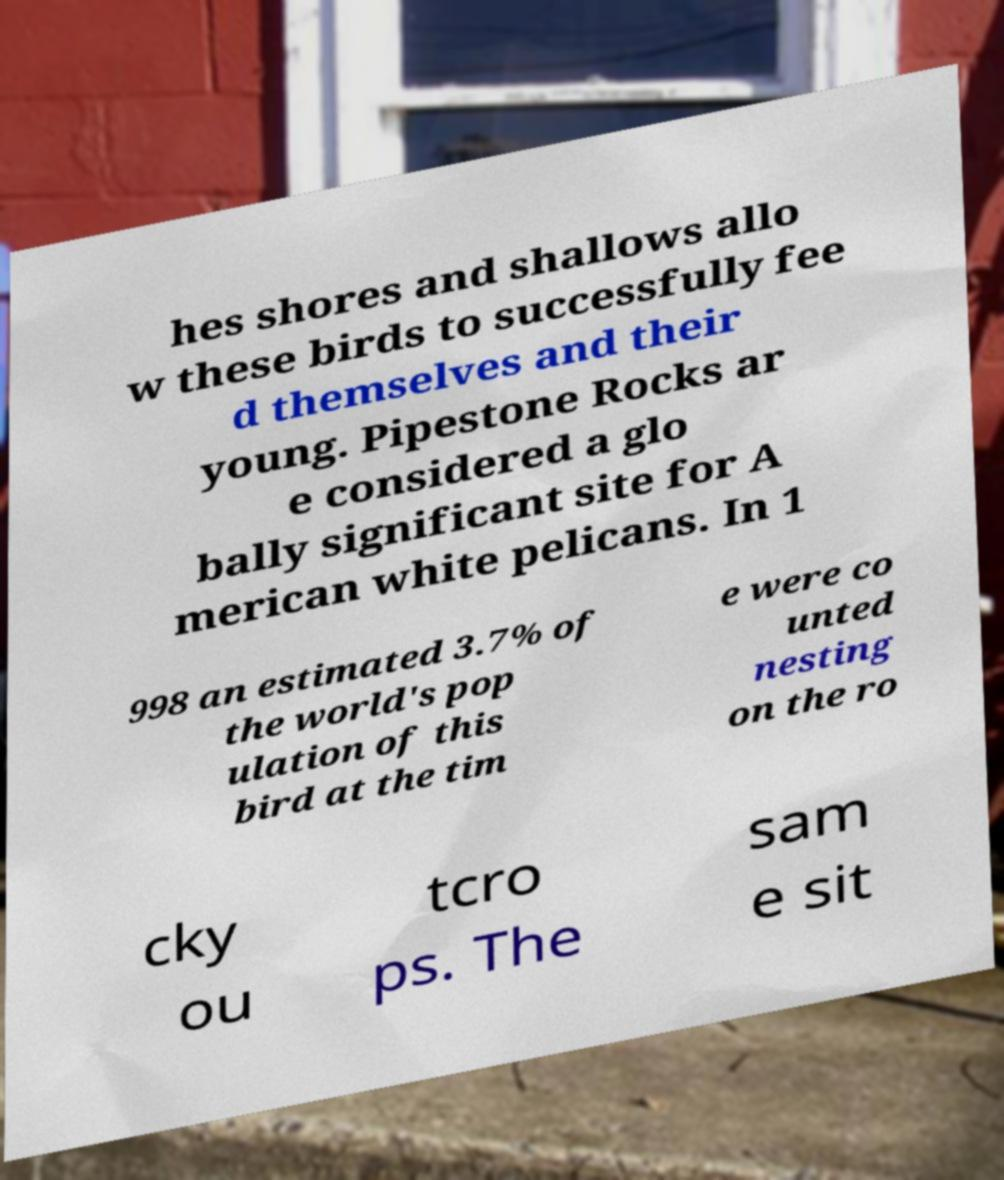Can you read and provide the text displayed in the image?This photo seems to have some interesting text. Can you extract and type it out for me? hes shores and shallows allo w these birds to successfully fee d themselves and their young. Pipestone Rocks ar e considered a glo bally significant site for A merican white pelicans. In 1 998 an estimated 3.7% of the world's pop ulation of this bird at the tim e were co unted nesting on the ro cky ou tcro ps. The sam e sit 